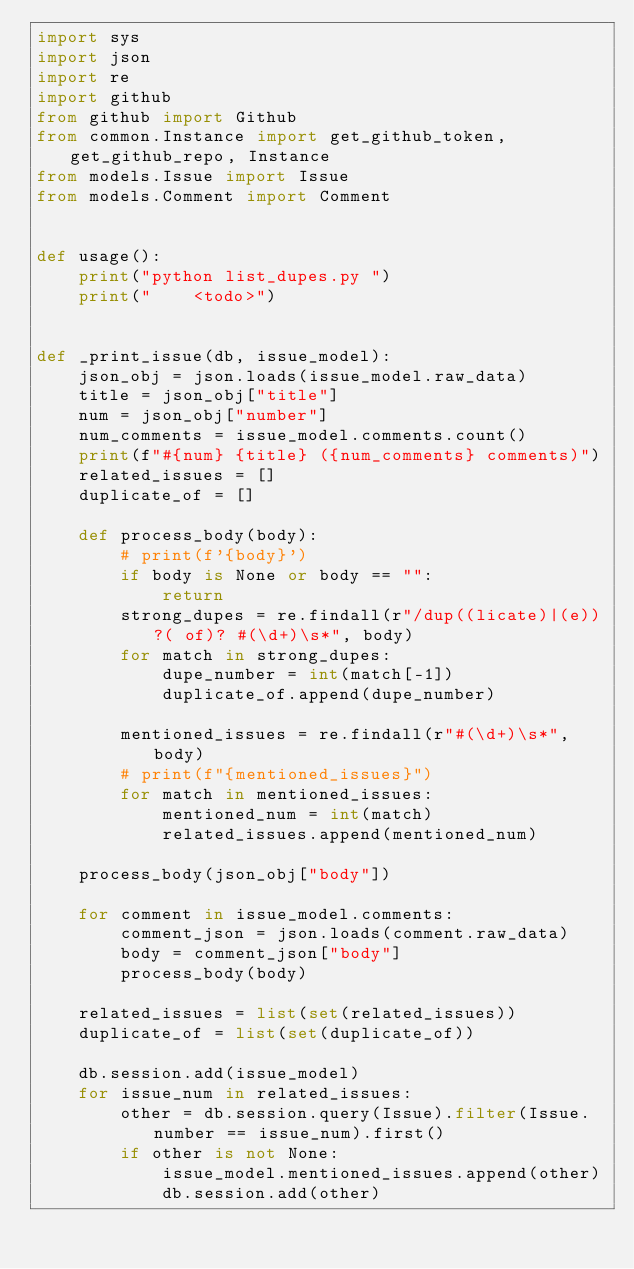Convert code to text. <code><loc_0><loc_0><loc_500><loc_500><_Python_>import sys
import json
import re
import github
from github import Github
from common.Instance import get_github_token, get_github_repo, Instance
from models.Issue import Issue
from models.Comment import Comment


def usage():
    print("python list_dupes.py ")
    print("    <todo>")


def _print_issue(db, issue_model):
    json_obj = json.loads(issue_model.raw_data)
    title = json_obj["title"]
    num = json_obj["number"]
    num_comments = issue_model.comments.count()
    print(f"#{num} {title} ({num_comments} comments)")
    related_issues = []
    duplicate_of = []

    def process_body(body):
        # print(f'{body}')
        if body is None or body == "":
            return
        strong_dupes = re.findall(r"/dup((licate)|(e))?( of)? #(\d+)\s*", body)
        for match in strong_dupes:
            dupe_number = int(match[-1])
            duplicate_of.append(dupe_number)

        mentioned_issues = re.findall(r"#(\d+)\s*", body)
        # print(f"{mentioned_issues}")
        for match in mentioned_issues:
            mentioned_num = int(match)
            related_issues.append(mentioned_num)

    process_body(json_obj["body"])

    for comment in issue_model.comments:
        comment_json = json.loads(comment.raw_data)
        body = comment_json["body"]
        process_body(body)

    related_issues = list(set(related_issues))
    duplicate_of = list(set(duplicate_of))

    db.session.add(issue_model)
    for issue_num in related_issues:
        other = db.session.query(Issue).filter(Issue.number == issue_num).first()
        if other is not None:
            issue_model.mentioned_issues.append(other)
            db.session.add(other)
</code> 